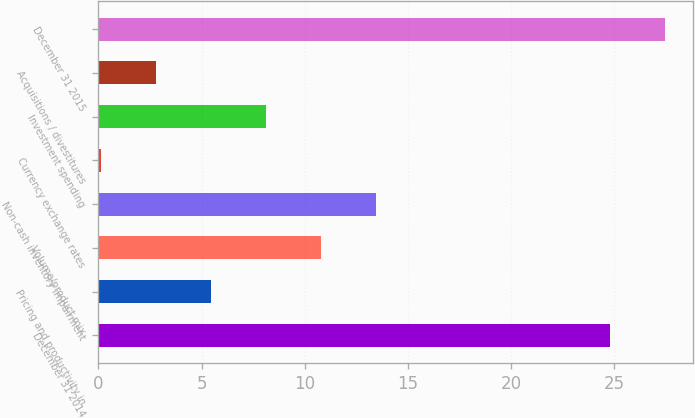Convert chart. <chart><loc_0><loc_0><loc_500><loc_500><bar_chart><fcel>December 31 2014<fcel>Pricing and productivity in<fcel>Volume/product mix<fcel>Non-cash inventory impairment<fcel>Currency exchange rates<fcel>Investment spending<fcel>Acquisitions / divestitures<fcel>December 31 2015<nl><fcel>24.8<fcel>5.44<fcel>10.78<fcel>13.45<fcel>0.1<fcel>8.11<fcel>2.77<fcel>27.47<nl></chart> 